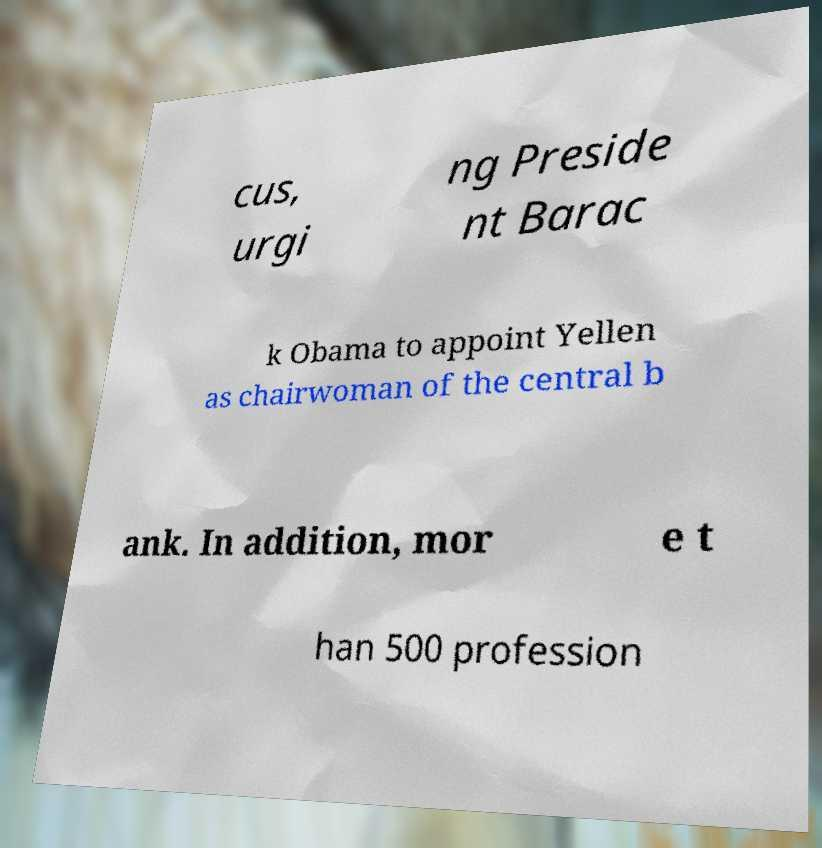Can you read and provide the text displayed in the image?This photo seems to have some interesting text. Can you extract and type it out for me? cus, urgi ng Preside nt Barac k Obama to appoint Yellen as chairwoman of the central b ank. In addition, mor e t han 500 profession 